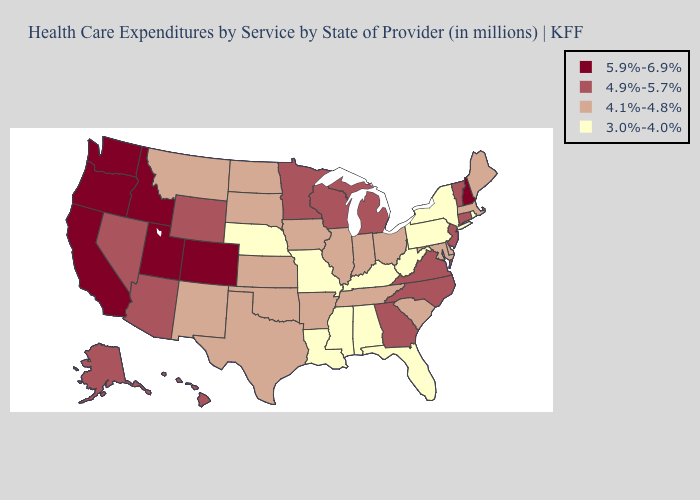What is the lowest value in the Northeast?
Answer briefly. 3.0%-4.0%. Among the states that border Massachusetts , does Rhode Island have the lowest value?
Write a very short answer. Yes. What is the value of Missouri?
Concise answer only. 3.0%-4.0%. Does Florida have a lower value than Louisiana?
Write a very short answer. No. Name the states that have a value in the range 3.0%-4.0%?
Answer briefly. Alabama, Florida, Kentucky, Louisiana, Mississippi, Missouri, Nebraska, New York, Pennsylvania, Rhode Island, West Virginia. What is the value of Missouri?
Write a very short answer. 3.0%-4.0%. Name the states that have a value in the range 4.9%-5.7%?
Answer briefly. Alaska, Arizona, Connecticut, Georgia, Hawaii, Michigan, Minnesota, Nevada, New Jersey, North Carolina, Vermont, Virginia, Wisconsin, Wyoming. Does the first symbol in the legend represent the smallest category?
Write a very short answer. No. What is the lowest value in the West?
Write a very short answer. 4.1%-4.8%. Among the states that border Tennessee , which have the highest value?
Concise answer only. Georgia, North Carolina, Virginia. Which states have the highest value in the USA?
Concise answer only. California, Colorado, Idaho, New Hampshire, Oregon, Utah, Washington. Is the legend a continuous bar?
Keep it brief. No. What is the value of Kansas?
Keep it brief. 4.1%-4.8%. What is the value of Minnesota?
Be succinct. 4.9%-5.7%. What is the lowest value in states that border South Carolina?
Keep it brief. 4.9%-5.7%. 